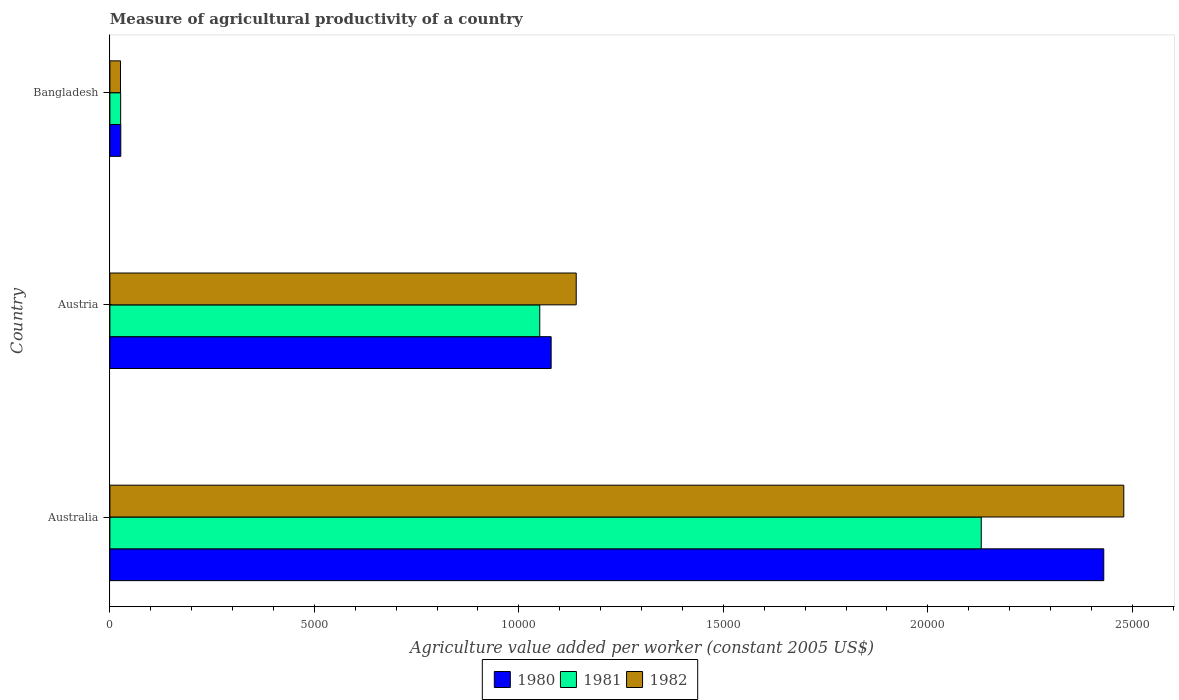Are the number of bars per tick equal to the number of legend labels?
Give a very brief answer. Yes. Are the number of bars on each tick of the Y-axis equal?
Your answer should be very brief. Yes. How many bars are there on the 2nd tick from the bottom?
Give a very brief answer. 3. What is the label of the 1st group of bars from the top?
Provide a succinct answer. Bangladesh. In how many cases, is the number of bars for a given country not equal to the number of legend labels?
Offer a very short reply. 0. What is the measure of agricultural productivity in 1982 in Australia?
Ensure brevity in your answer.  2.48e+04. Across all countries, what is the maximum measure of agricultural productivity in 1980?
Offer a very short reply. 2.43e+04. Across all countries, what is the minimum measure of agricultural productivity in 1981?
Offer a very short reply. 263.41. What is the total measure of agricultural productivity in 1981 in the graph?
Your answer should be compact. 3.21e+04. What is the difference between the measure of agricultural productivity in 1980 in Australia and that in Austria?
Make the answer very short. 1.35e+04. What is the difference between the measure of agricultural productivity in 1982 in Bangladesh and the measure of agricultural productivity in 1981 in Australia?
Offer a terse response. -2.10e+04. What is the average measure of agricultural productivity in 1982 per country?
Ensure brevity in your answer.  1.22e+04. What is the difference between the measure of agricultural productivity in 1981 and measure of agricultural productivity in 1980 in Austria?
Your answer should be compact. -278.31. What is the ratio of the measure of agricultural productivity in 1981 in Austria to that in Bangladesh?
Provide a succinct answer. 39.91. Is the measure of agricultural productivity in 1982 in Austria less than that in Bangladesh?
Your response must be concise. No. What is the difference between the highest and the second highest measure of agricultural productivity in 1982?
Your response must be concise. 1.34e+04. What is the difference between the highest and the lowest measure of agricultural productivity in 1980?
Make the answer very short. 2.40e+04. What does the 2nd bar from the top in Australia represents?
Provide a short and direct response. 1981. What does the 1st bar from the bottom in Australia represents?
Your answer should be compact. 1980. Are all the bars in the graph horizontal?
Make the answer very short. Yes. How many countries are there in the graph?
Make the answer very short. 3. Does the graph contain grids?
Ensure brevity in your answer.  No. Where does the legend appear in the graph?
Provide a succinct answer. Bottom center. How many legend labels are there?
Offer a very short reply. 3. What is the title of the graph?
Your answer should be very brief. Measure of agricultural productivity of a country. Does "2009" appear as one of the legend labels in the graph?
Ensure brevity in your answer.  No. What is the label or title of the X-axis?
Ensure brevity in your answer.  Agriculture value added per worker (constant 2005 US$). What is the label or title of the Y-axis?
Provide a short and direct response. Country. What is the Agriculture value added per worker (constant 2005 US$) in 1980 in Australia?
Provide a succinct answer. 2.43e+04. What is the Agriculture value added per worker (constant 2005 US$) of 1981 in Australia?
Your answer should be compact. 2.13e+04. What is the Agriculture value added per worker (constant 2005 US$) of 1982 in Australia?
Provide a short and direct response. 2.48e+04. What is the Agriculture value added per worker (constant 2005 US$) of 1980 in Austria?
Keep it short and to the point. 1.08e+04. What is the Agriculture value added per worker (constant 2005 US$) of 1981 in Austria?
Your answer should be very brief. 1.05e+04. What is the Agriculture value added per worker (constant 2005 US$) in 1982 in Austria?
Give a very brief answer. 1.14e+04. What is the Agriculture value added per worker (constant 2005 US$) of 1980 in Bangladesh?
Give a very brief answer. 266.12. What is the Agriculture value added per worker (constant 2005 US$) of 1981 in Bangladesh?
Provide a short and direct response. 263.41. What is the Agriculture value added per worker (constant 2005 US$) in 1982 in Bangladesh?
Your answer should be very brief. 259.74. Across all countries, what is the maximum Agriculture value added per worker (constant 2005 US$) of 1980?
Your answer should be compact. 2.43e+04. Across all countries, what is the maximum Agriculture value added per worker (constant 2005 US$) in 1981?
Your answer should be compact. 2.13e+04. Across all countries, what is the maximum Agriculture value added per worker (constant 2005 US$) of 1982?
Offer a terse response. 2.48e+04. Across all countries, what is the minimum Agriculture value added per worker (constant 2005 US$) in 1980?
Offer a terse response. 266.12. Across all countries, what is the minimum Agriculture value added per worker (constant 2005 US$) of 1981?
Keep it short and to the point. 263.41. Across all countries, what is the minimum Agriculture value added per worker (constant 2005 US$) of 1982?
Your answer should be compact. 259.74. What is the total Agriculture value added per worker (constant 2005 US$) in 1980 in the graph?
Provide a succinct answer. 3.54e+04. What is the total Agriculture value added per worker (constant 2005 US$) in 1981 in the graph?
Make the answer very short. 3.21e+04. What is the total Agriculture value added per worker (constant 2005 US$) of 1982 in the graph?
Provide a succinct answer. 3.65e+04. What is the difference between the Agriculture value added per worker (constant 2005 US$) of 1980 in Australia and that in Austria?
Your answer should be very brief. 1.35e+04. What is the difference between the Agriculture value added per worker (constant 2005 US$) in 1981 in Australia and that in Austria?
Ensure brevity in your answer.  1.08e+04. What is the difference between the Agriculture value added per worker (constant 2005 US$) in 1982 in Australia and that in Austria?
Offer a terse response. 1.34e+04. What is the difference between the Agriculture value added per worker (constant 2005 US$) in 1980 in Australia and that in Bangladesh?
Provide a short and direct response. 2.40e+04. What is the difference between the Agriculture value added per worker (constant 2005 US$) of 1981 in Australia and that in Bangladesh?
Your response must be concise. 2.10e+04. What is the difference between the Agriculture value added per worker (constant 2005 US$) in 1982 in Australia and that in Bangladesh?
Your response must be concise. 2.45e+04. What is the difference between the Agriculture value added per worker (constant 2005 US$) of 1980 in Austria and that in Bangladesh?
Provide a succinct answer. 1.05e+04. What is the difference between the Agriculture value added per worker (constant 2005 US$) in 1981 in Austria and that in Bangladesh?
Offer a very short reply. 1.02e+04. What is the difference between the Agriculture value added per worker (constant 2005 US$) of 1982 in Austria and that in Bangladesh?
Provide a short and direct response. 1.11e+04. What is the difference between the Agriculture value added per worker (constant 2005 US$) in 1980 in Australia and the Agriculture value added per worker (constant 2005 US$) in 1981 in Austria?
Keep it short and to the point. 1.38e+04. What is the difference between the Agriculture value added per worker (constant 2005 US$) in 1980 in Australia and the Agriculture value added per worker (constant 2005 US$) in 1982 in Austria?
Offer a very short reply. 1.29e+04. What is the difference between the Agriculture value added per worker (constant 2005 US$) in 1981 in Australia and the Agriculture value added per worker (constant 2005 US$) in 1982 in Austria?
Keep it short and to the point. 9904.54. What is the difference between the Agriculture value added per worker (constant 2005 US$) in 1980 in Australia and the Agriculture value added per worker (constant 2005 US$) in 1981 in Bangladesh?
Provide a succinct answer. 2.40e+04. What is the difference between the Agriculture value added per worker (constant 2005 US$) in 1980 in Australia and the Agriculture value added per worker (constant 2005 US$) in 1982 in Bangladesh?
Your answer should be compact. 2.40e+04. What is the difference between the Agriculture value added per worker (constant 2005 US$) of 1981 in Australia and the Agriculture value added per worker (constant 2005 US$) of 1982 in Bangladesh?
Your answer should be very brief. 2.10e+04. What is the difference between the Agriculture value added per worker (constant 2005 US$) in 1980 in Austria and the Agriculture value added per worker (constant 2005 US$) in 1981 in Bangladesh?
Provide a succinct answer. 1.05e+04. What is the difference between the Agriculture value added per worker (constant 2005 US$) in 1980 in Austria and the Agriculture value added per worker (constant 2005 US$) in 1982 in Bangladesh?
Your response must be concise. 1.05e+04. What is the difference between the Agriculture value added per worker (constant 2005 US$) of 1981 in Austria and the Agriculture value added per worker (constant 2005 US$) of 1982 in Bangladesh?
Provide a succinct answer. 1.03e+04. What is the average Agriculture value added per worker (constant 2005 US$) of 1980 per country?
Offer a very short reply. 1.18e+04. What is the average Agriculture value added per worker (constant 2005 US$) in 1981 per country?
Give a very brief answer. 1.07e+04. What is the average Agriculture value added per worker (constant 2005 US$) in 1982 per country?
Give a very brief answer. 1.22e+04. What is the difference between the Agriculture value added per worker (constant 2005 US$) of 1980 and Agriculture value added per worker (constant 2005 US$) of 1981 in Australia?
Ensure brevity in your answer.  2995.46. What is the difference between the Agriculture value added per worker (constant 2005 US$) of 1980 and Agriculture value added per worker (constant 2005 US$) of 1982 in Australia?
Your answer should be compact. -489.66. What is the difference between the Agriculture value added per worker (constant 2005 US$) in 1981 and Agriculture value added per worker (constant 2005 US$) in 1982 in Australia?
Provide a short and direct response. -3485.12. What is the difference between the Agriculture value added per worker (constant 2005 US$) in 1980 and Agriculture value added per worker (constant 2005 US$) in 1981 in Austria?
Ensure brevity in your answer.  278.31. What is the difference between the Agriculture value added per worker (constant 2005 US$) in 1980 and Agriculture value added per worker (constant 2005 US$) in 1982 in Austria?
Give a very brief answer. -613.06. What is the difference between the Agriculture value added per worker (constant 2005 US$) in 1981 and Agriculture value added per worker (constant 2005 US$) in 1982 in Austria?
Offer a terse response. -891.36. What is the difference between the Agriculture value added per worker (constant 2005 US$) of 1980 and Agriculture value added per worker (constant 2005 US$) of 1981 in Bangladesh?
Your answer should be very brief. 2.71. What is the difference between the Agriculture value added per worker (constant 2005 US$) of 1980 and Agriculture value added per worker (constant 2005 US$) of 1982 in Bangladesh?
Your answer should be very brief. 6.38. What is the difference between the Agriculture value added per worker (constant 2005 US$) of 1981 and Agriculture value added per worker (constant 2005 US$) of 1982 in Bangladesh?
Your answer should be compact. 3.67. What is the ratio of the Agriculture value added per worker (constant 2005 US$) of 1980 in Australia to that in Austria?
Your answer should be very brief. 2.25. What is the ratio of the Agriculture value added per worker (constant 2005 US$) in 1981 in Australia to that in Austria?
Your response must be concise. 2.03. What is the ratio of the Agriculture value added per worker (constant 2005 US$) in 1982 in Australia to that in Austria?
Offer a very short reply. 2.17. What is the ratio of the Agriculture value added per worker (constant 2005 US$) of 1980 in Australia to that in Bangladesh?
Provide a succinct answer. 91.32. What is the ratio of the Agriculture value added per worker (constant 2005 US$) in 1981 in Australia to that in Bangladesh?
Ensure brevity in your answer.  80.89. What is the ratio of the Agriculture value added per worker (constant 2005 US$) of 1982 in Australia to that in Bangladesh?
Your answer should be compact. 95.45. What is the ratio of the Agriculture value added per worker (constant 2005 US$) in 1980 in Austria to that in Bangladesh?
Your answer should be compact. 40.55. What is the ratio of the Agriculture value added per worker (constant 2005 US$) of 1981 in Austria to that in Bangladesh?
Offer a very short reply. 39.91. What is the ratio of the Agriculture value added per worker (constant 2005 US$) of 1982 in Austria to that in Bangladesh?
Your response must be concise. 43.9. What is the difference between the highest and the second highest Agriculture value added per worker (constant 2005 US$) of 1980?
Offer a terse response. 1.35e+04. What is the difference between the highest and the second highest Agriculture value added per worker (constant 2005 US$) in 1981?
Give a very brief answer. 1.08e+04. What is the difference between the highest and the second highest Agriculture value added per worker (constant 2005 US$) of 1982?
Offer a very short reply. 1.34e+04. What is the difference between the highest and the lowest Agriculture value added per worker (constant 2005 US$) of 1980?
Offer a very short reply. 2.40e+04. What is the difference between the highest and the lowest Agriculture value added per worker (constant 2005 US$) in 1981?
Give a very brief answer. 2.10e+04. What is the difference between the highest and the lowest Agriculture value added per worker (constant 2005 US$) in 1982?
Make the answer very short. 2.45e+04. 